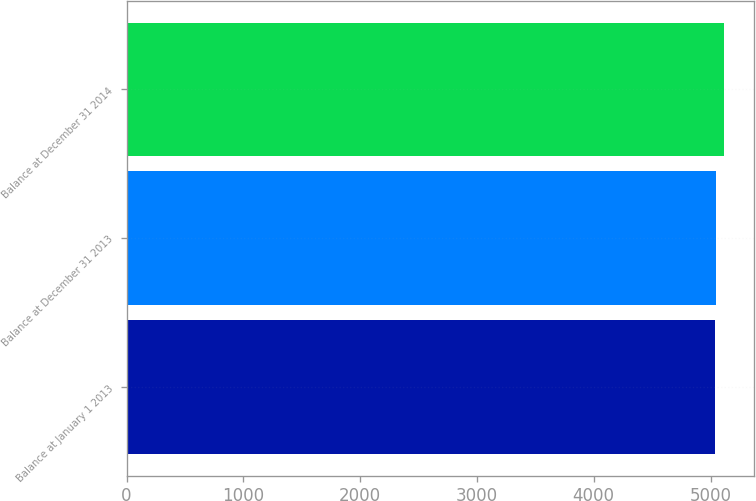<chart> <loc_0><loc_0><loc_500><loc_500><bar_chart><fcel>Balance at January 1 2013<fcel>Balance at December 31 2013<fcel>Balance at December 31 2014<nl><fcel>5035<fcel>5043.4<fcel>5119<nl></chart> 